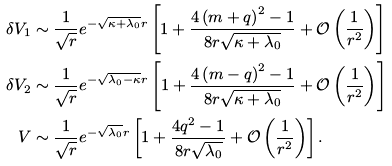<formula> <loc_0><loc_0><loc_500><loc_500>\delta V _ { 1 } & \sim \frac { 1 } { \sqrt { r } } e ^ { - \sqrt { \kappa + \lambda _ { 0 } } r } \left [ 1 + \frac { 4 \left ( m + q \right ) ^ { 2 } - 1 } { 8 r \sqrt { \kappa + \lambda _ { 0 } } } + \mathcal { O } \left ( \frac { 1 } { r ^ { 2 } } \right ) \right ] \\ \delta V _ { 2 } & \sim \frac { 1 } { \sqrt { r } } e ^ { - \sqrt { \lambda _ { 0 } - \kappa } r } \left [ 1 + \frac { 4 \left ( m - q \right ) ^ { 2 } - 1 } { 8 r \sqrt { \kappa + \lambda _ { 0 } } } + \mathcal { O } \left ( \frac { 1 } { r ^ { 2 } } \right ) \right ] \\ V & \sim \frac { 1 } { \sqrt { r } } e ^ { - \sqrt { \lambda _ { 0 } } r } \left [ 1 + \frac { 4 q ^ { 2 } - 1 } { 8 r \sqrt { \lambda _ { 0 } } } + \mathcal { O } \left ( \frac { 1 } { r ^ { 2 } } \right ) \right ] .</formula> 